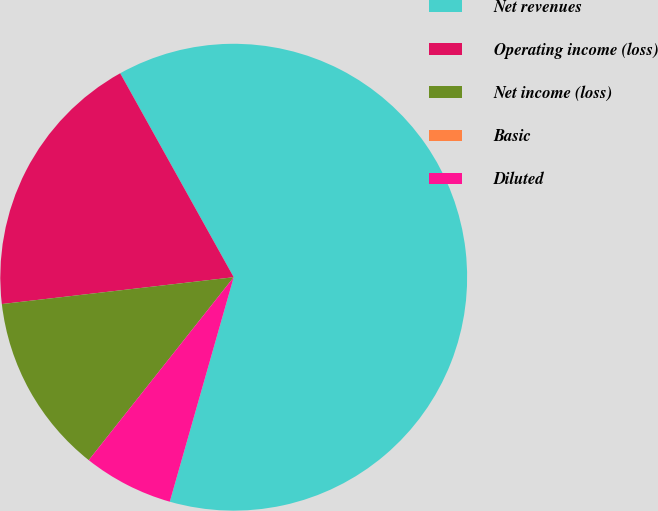Convert chart to OTSL. <chart><loc_0><loc_0><loc_500><loc_500><pie_chart><fcel>Net revenues<fcel>Operating income (loss)<fcel>Net income (loss)<fcel>Basic<fcel>Diluted<nl><fcel>62.5%<fcel>18.75%<fcel>12.5%<fcel>0.0%<fcel>6.25%<nl></chart> 